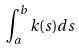<formula> <loc_0><loc_0><loc_500><loc_500>\int _ { a } ^ { b } k ( s ) d s</formula> 